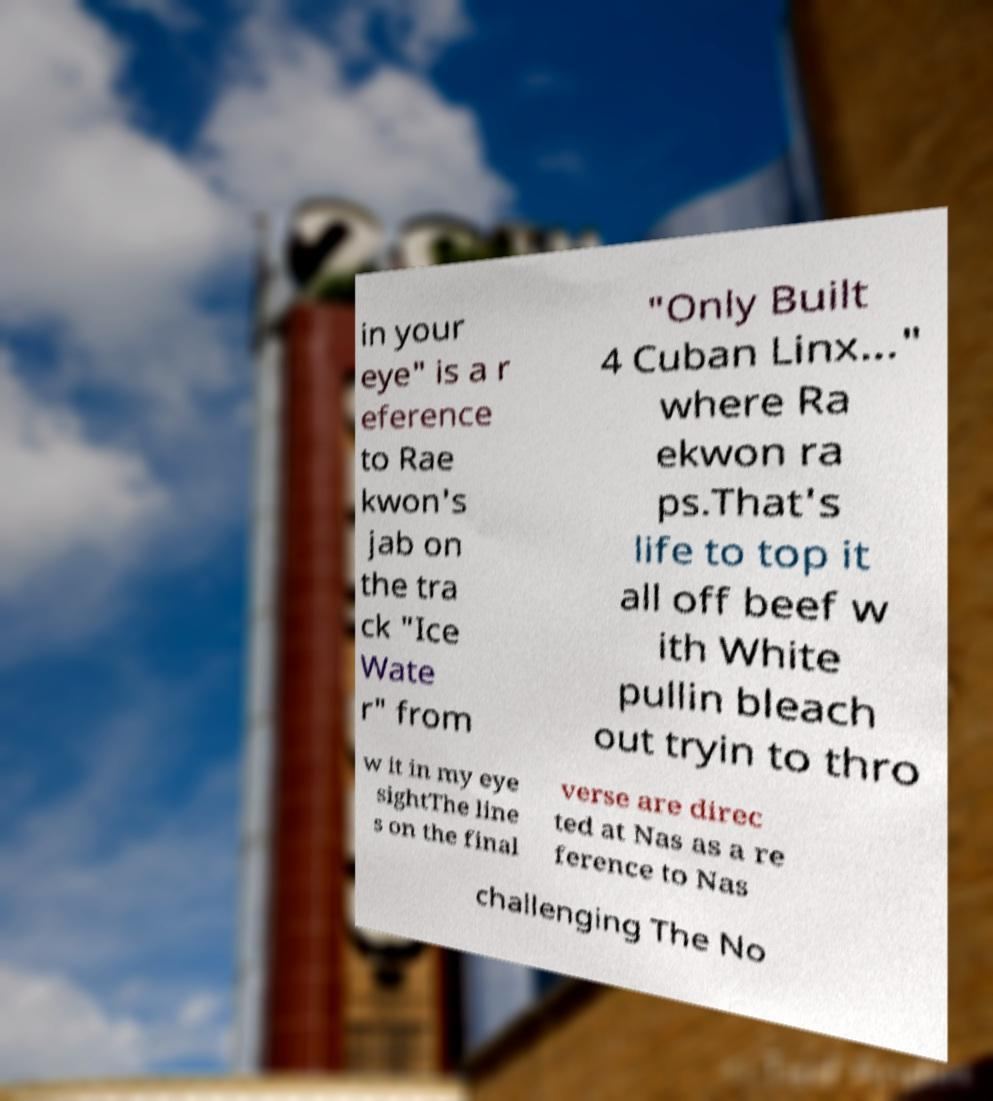Could you extract and type out the text from this image? in your eye" is a r eference to Rae kwon's jab on the tra ck "Ice Wate r" from "Only Built 4 Cuban Linx..." where Ra ekwon ra ps.That's life to top it all off beef w ith White pullin bleach out tryin to thro w it in my eye sightThe line s on the final verse are direc ted at Nas as a re ference to Nas challenging The No 